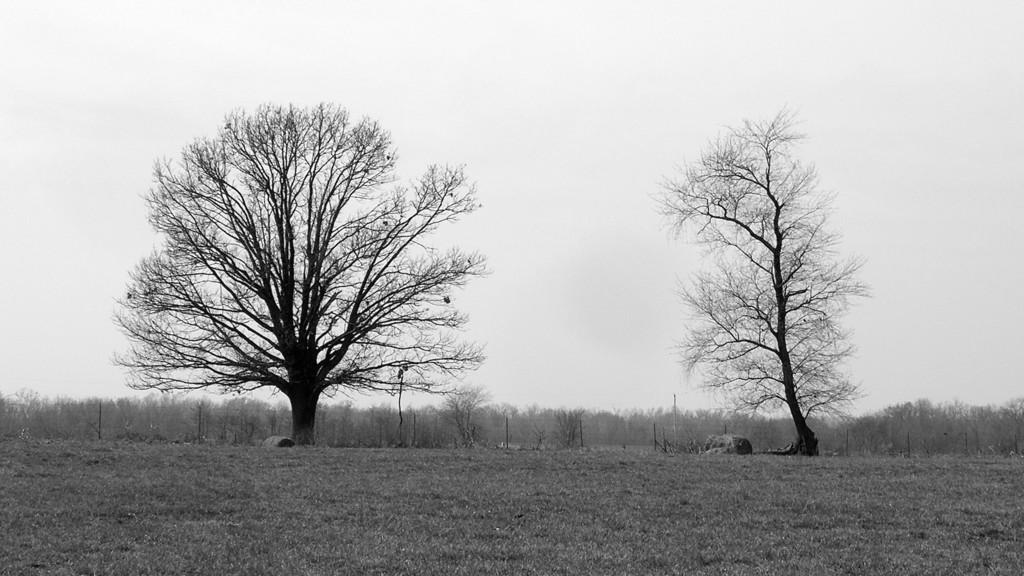What is located in the middle of the image? There are trees in the middle of the image. What is visible at the top of the image? The sky is visible at the top of the image. What color scheme is used in the image? The image is in black and white color. Can you see any balloons in the image? There are no balloons present in the image. Is there any indication of death in the image? There is no indication of death in the image. 